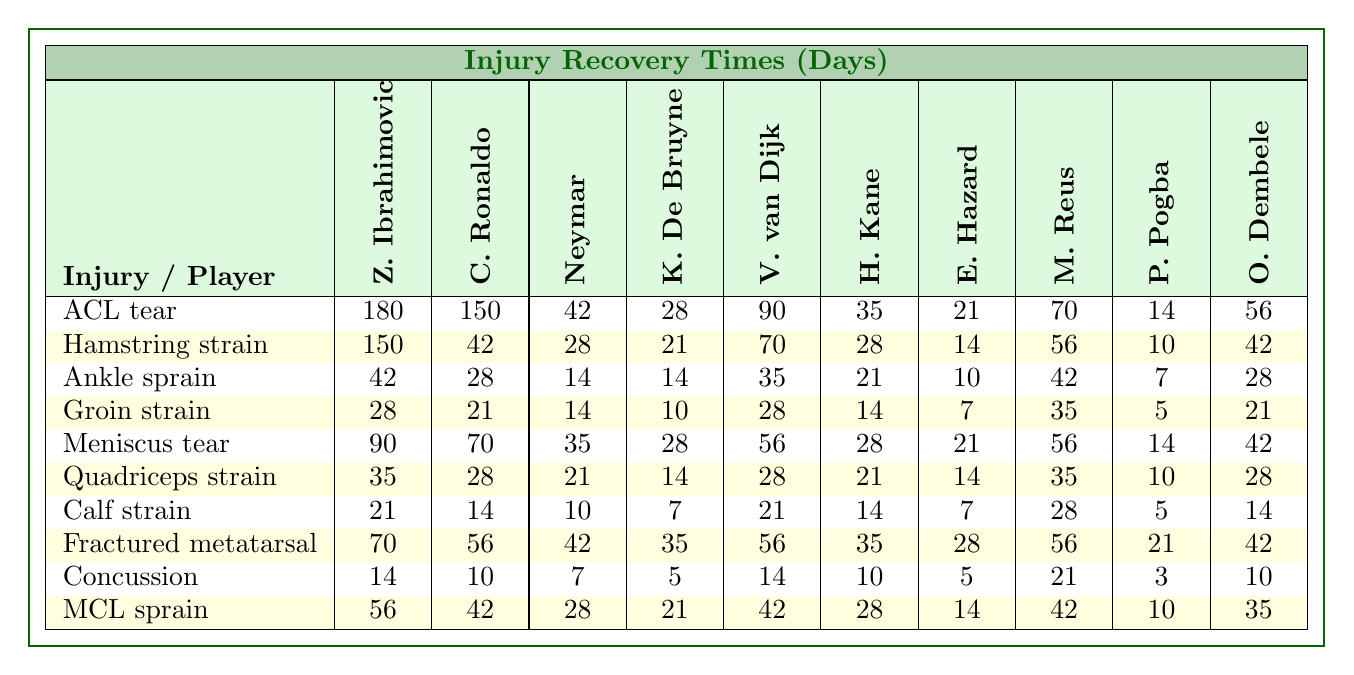What is the recovery time for Zlatan Ibrahimovic for an ACL tear? The table shows that Zlatan Ibrahimovic has a recovery time of 180 days for an ACL tear.
Answer: 180 days Which player has the shortest recovery time for a concussion? Looking at the table, Ousmane Dembele has the shortest recovery time for a concussion with 10 days.
Answer: 10 days On average, how long does it take for players to recover from a calf strain? The recovery times for a calf strain across all players are (21 + 14 + 10 + 7 + 21 + 14 + 7 + 28 + 5 + 14) = 121 days. There are 10 players, so the average is 121 / 10 = 12.1 days.
Answer: 12.1 days Is the recovery time for a hamstring strain greater than 100 days for any player? The table shows the recovery times for a hamstring strain are 150, 42, 28, 21, 70, 28, 14, 56, 10, and 42 days. The maximum recovery time is 150 days which is greater than 100 days.
Answer: Yes Who has a shorter recovery time for a groin strain, Kevin De Bruyne or Virgil van Dijk? The recovery time for Kevin De Bruyne is 10 days and for Virgil van Dijk is 28 days according to the table. Therefore, Kevin De Bruyne has a shorter recovery time.
Answer: Kevin De Bruyne What is the total recovery time for all players for an ankle sprain? Summing the recovery times for an ankle sprain gives (42 + 28 + 14 + 14 + 35 + 21 + 10 + 42 + 7 + 28) = 314 days.
Answer: 314 days Which injury has the longest average recovery time among all players? The average recovery times must be calculated for each injury. The ACL tear has the highest recovery time when calculated, with an average of (180 + 150 + 42 + 28 + 90 + 35 + 21 + 70 + 14 + 56) = 1205 days / 10 = 120.5 days.
Answer: ACL tear Is there a player who recovers from a fractured metatarsal in 35 days? The table displays 70, 56, 42, 35, 56, 35, 28, 56, 21, and 42 days for recovery from a fractured metatarsal. It shows Kevin De Bruyne and Eden Hazard both recover in 35 days.
Answer: Yes Which injury type has the maximum recovery time for Harry Kane and what is that duration? The maximum recovery time for Harry Kane is for ACL tear, which is 35 days according to the table.
Answer: ACL tear, 35 days 